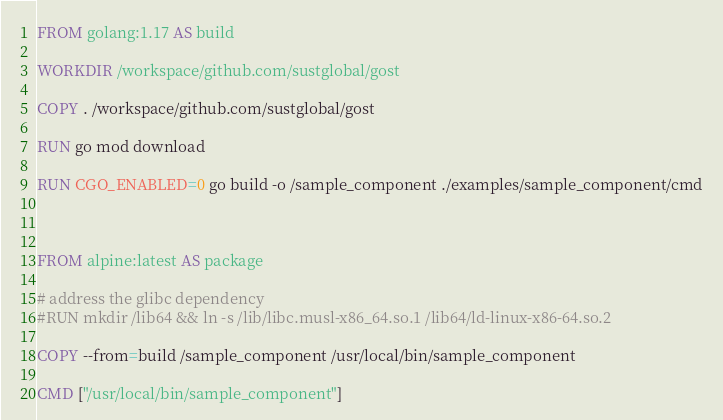<code> <loc_0><loc_0><loc_500><loc_500><_Dockerfile_>FROM golang:1.17 AS build

WORKDIR /workspace/github.com/sustglobal/gost

COPY . /workspace/github.com/sustglobal/gost

RUN go mod download

RUN CGO_ENABLED=0 go build -o /sample_component ./examples/sample_component/cmd



FROM alpine:latest AS package

# address the glibc dependency
#RUN mkdir /lib64 && ln -s /lib/libc.musl-x86_64.so.1 /lib64/ld-linux-x86-64.so.2

COPY --from=build /sample_component /usr/local/bin/sample_component

CMD ["/usr/local/bin/sample_component"]
</code> 